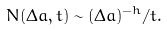<formula> <loc_0><loc_0><loc_500><loc_500>N ( \Delta a , t ) \sim ( \Delta a ) ^ { - h } / t .</formula> 